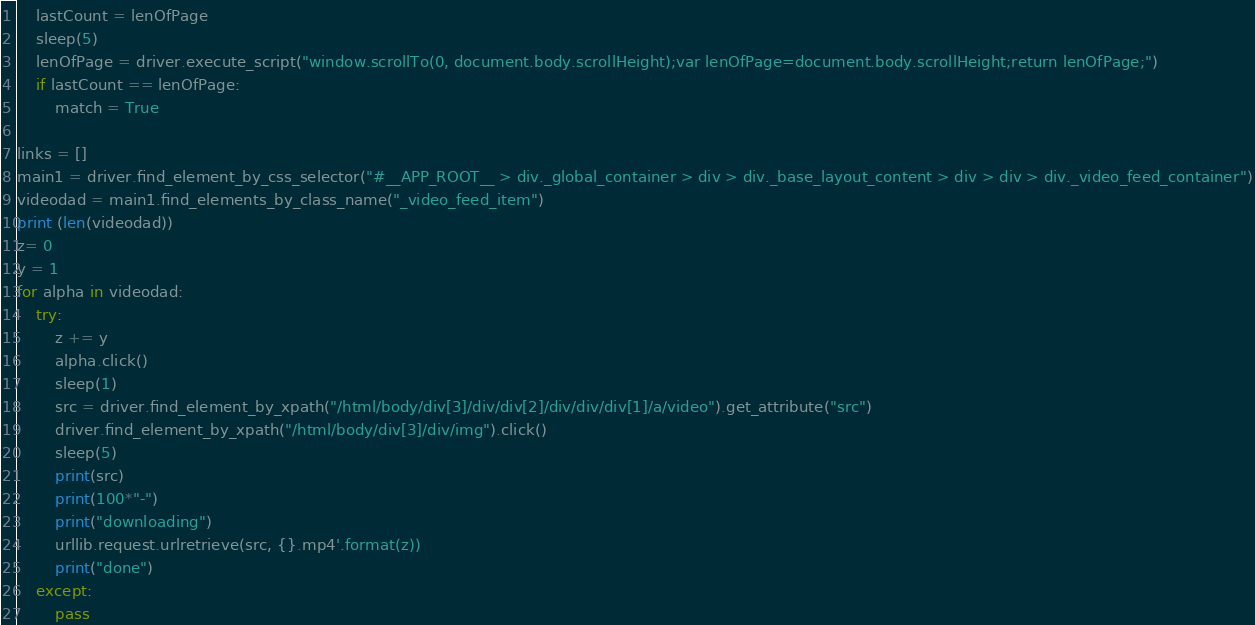<code> <loc_0><loc_0><loc_500><loc_500><_Python_>    lastCount = lenOfPage
    sleep(5)
    lenOfPage = driver.execute_script("window.scrollTo(0, document.body.scrollHeight);var lenOfPage=document.body.scrollHeight;return lenOfPage;")
    if lastCount == lenOfPage:
        match = True

links = []
main1 = driver.find_element_by_css_selector("#__APP_ROOT__ > div._global_container > div > div._base_layout_content > div > div > div._video_feed_container")
videodad = main1.find_elements_by_class_name("_video_feed_item")
print (len(videodad))
z= 0
y = 1
for alpha in videodad:
    try:
        z += y
        alpha.click()
        sleep(1)
        src = driver.find_element_by_xpath("/html/body/div[3]/div/div[2]/div/div/div[1]/a/video").get_attribute("src")
        driver.find_element_by_xpath("/html/body/div[3]/div/img").click()
        sleep(5)
        print(src)
        print(100*"-")
        print("downloading")
        urllib.request.urlretrieve(src, {}.mp4'.format(z)) 
        print("done")
    except:
        pass
</code> 